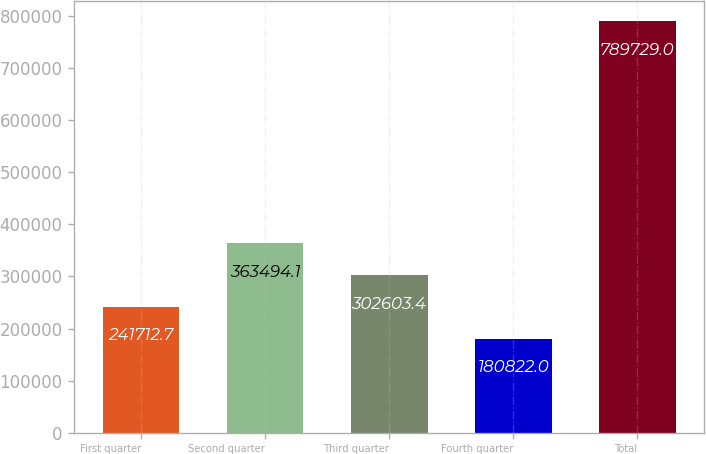Convert chart. <chart><loc_0><loc_0><loc_500><loc_500><bar_chart><fcel>First quarter<fcel>Second quarter<fcel>Third quarter<fcel>Fourth quarter<fcel>Total<nl><fcel>241713<fcel>363494<fcel>302603<fcel>180822<fcel>789729<nl></chart> 